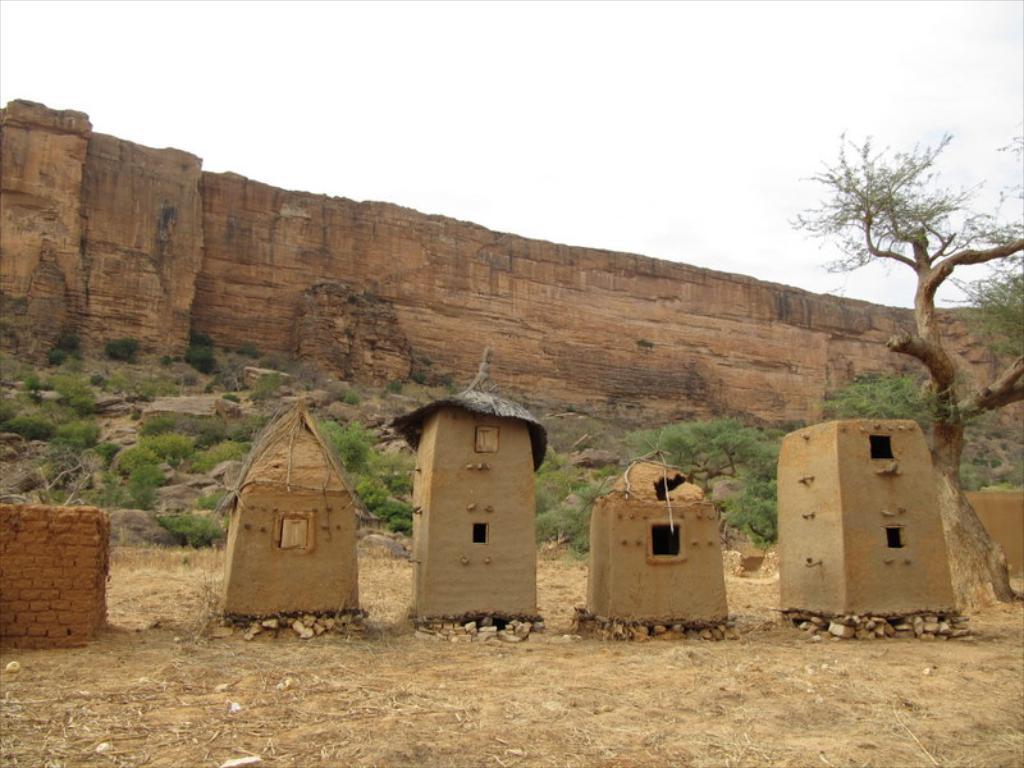How would you summarize this image in a sentence or two? In this picture we can see huts, in the background we can find few trees and rocks. 